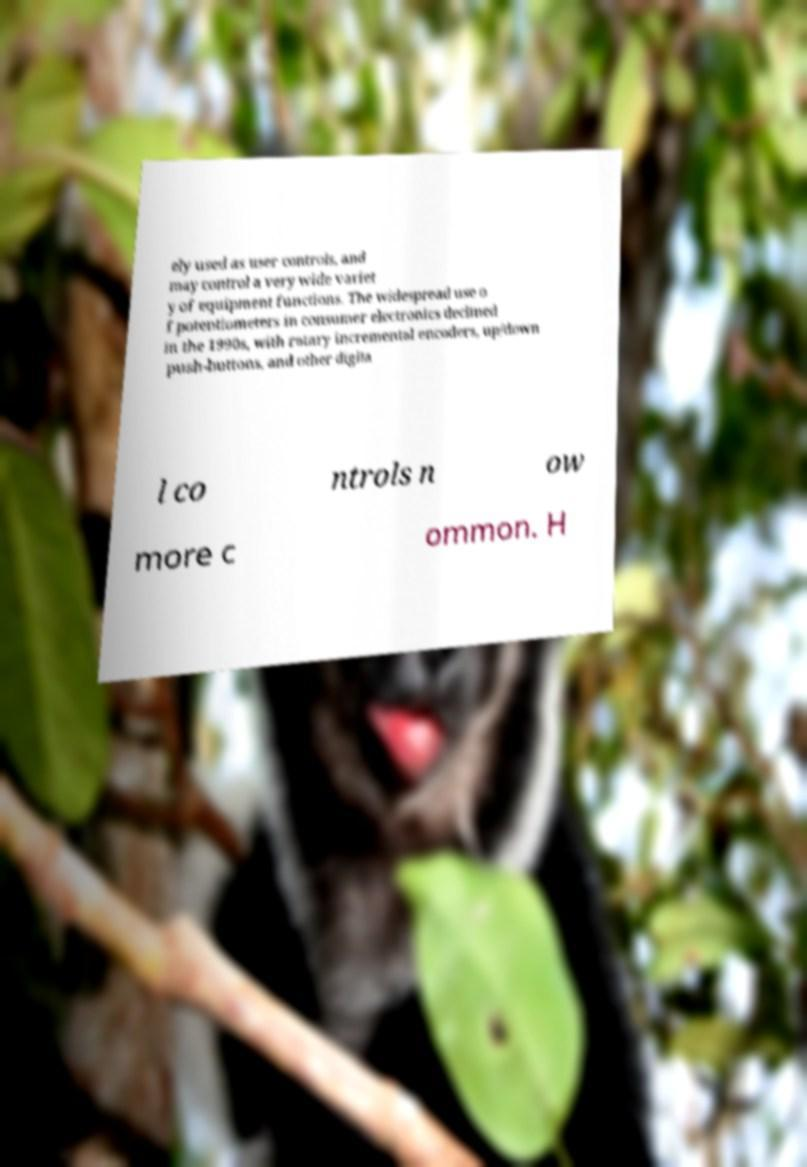Could you assist in decoding the text presented in this image and type it out clearly? ely used as user controls, and may control a very wide variet y of equipment functions. The widespread use o f potentiometers in consumer electronics declined in the 1990s, with rotary incremental encoders, up/down push-buttons, and other digita l co ntrols n ow more c ommon. H 